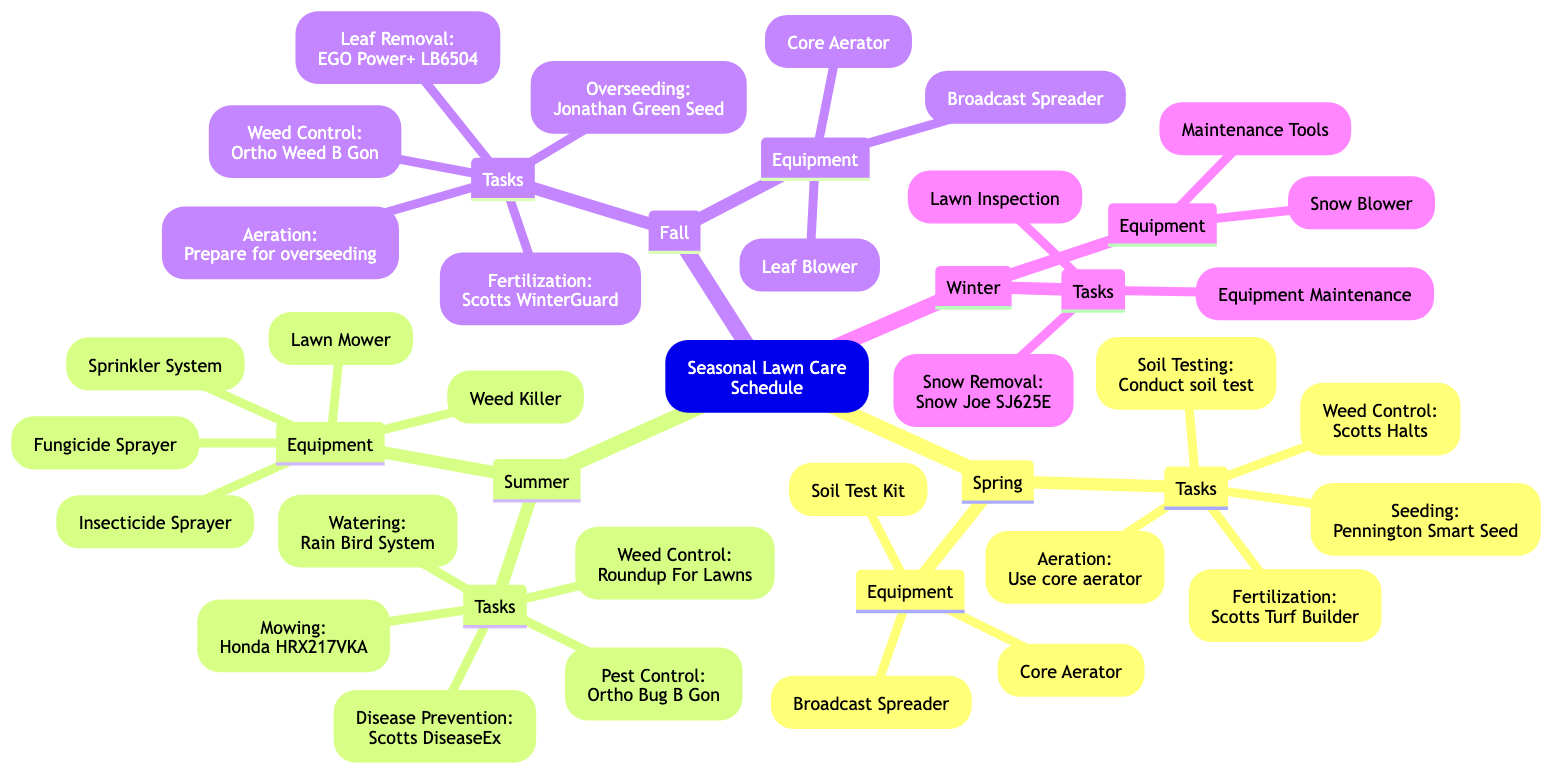What are the tasks listed under Fall? The Fall section includes tasks such as Aeration, Overseeding, Fertilization, Leaf Removal, and Weed Control. Each task is directly listed under the Tasks node in the Fall section of the mind map.
Answer: Aeration, Overseeding, Fertilization, Leaf Removal, Weed Control How many tasks are listed for Summer? The Summer section contains five tasks: Mowing, Watering, Weed Control, Pest Control, and Disease Prevention. By counting these tasks, we find there are a total of five.
Answer: 5 Which equipment is recommended for Spring? The Spring section lists the recommended equipment as Core Aerator, Broadcast Spreader, and Soil Test Kit. These are specified under the Equipment node for the Spring section.
Answer: Core Aerator, Broadcast Spreader, Soil Test Kit What product is suggested for fall fertilization? According to the diagram, the recommended product for fall fertilization is Scotts WinterGuard Fall Lawn Food, which is listed directly under the Fertilization task for Fall.
Answer: Scotts WinterGuard Fall Lawn Food During which season should you use a snow blower? The Winter section explicitly lists the Snow Blower as one of the pieces of equipment required for the winter season and mentions snow removal tasks. Thus, it is appropriate to use a snow blower in Winter.
Answer: Winter What is the primary purpose of the equipment listed in the Summer section? The Summer equipment includes tools for tasks such as mowing, watering, weed control, pest control, and disease prevention. Each piece of equipment is specifically related to maintaining a healthy lawn during summer, indicating their combined purpose for active lawn care.
Answer: Active lawn care Which season includes the task of soil testing? The task of soil testing is listed under the Spring section, where it directly falls under the relevant tasks for preparing the lawn in the springtime.
Answer: Spring How many types of equipment are mentioned for the Winter season? There are two types of equipment listed for the Winter season: Snow Blower and Lawn Maintenance Tools. Thus, when counting the items listed, the total is two types of equipment.
Answer: 2 Which specific product is used for pest control in Summer? The Summer section specifies that pest control is achieved using Ortho Bug B Gon, which is mentioned directly under the Pest Control task.
Answer: Ortho Bug B Gon 